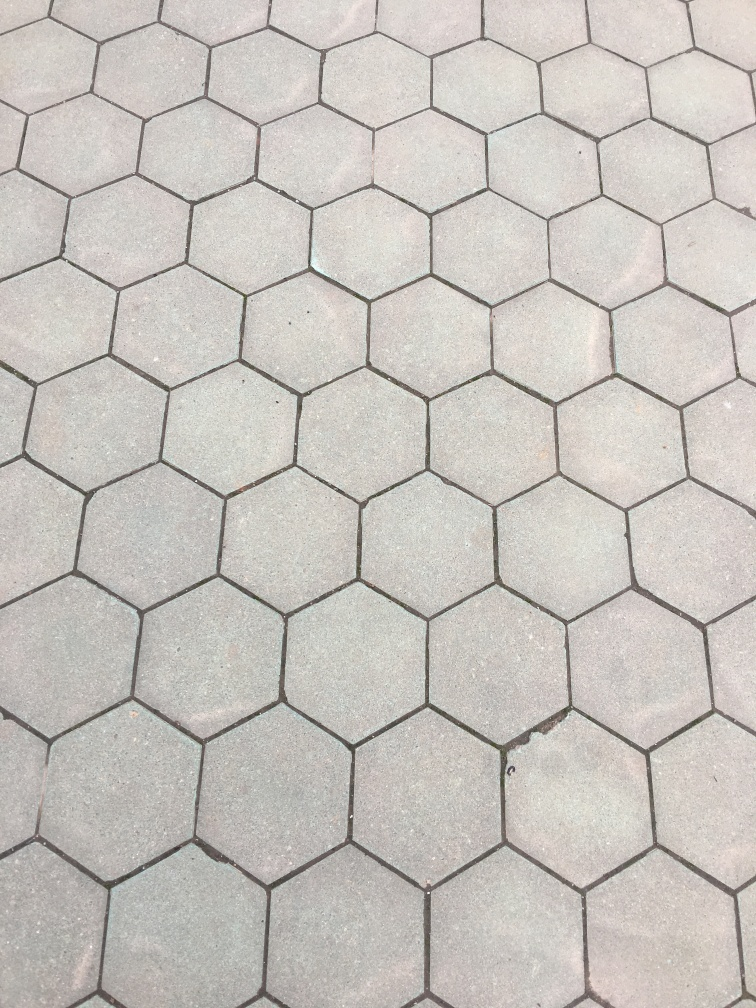Can you tell me what this image could be used for? Certainly, the image showcases a pavement pattern that can be used for urban planning or architecture presentations, reflecting on public space design and the materials used in pedestrian areas. 